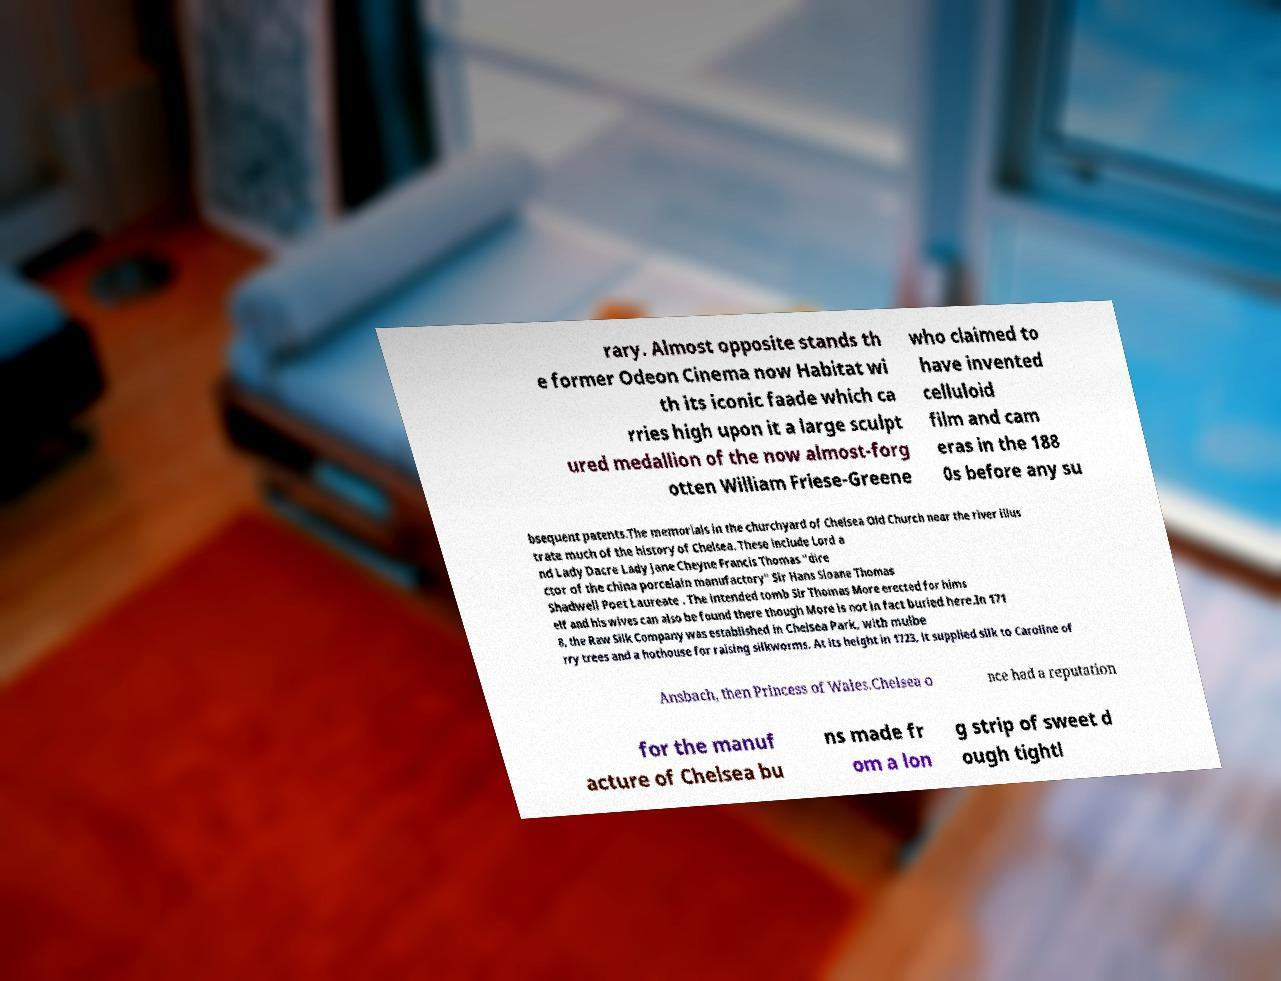Can you accurately transcribe the text from the provided image for me? rary. Almost opposite stands th e former Odeon Cinema now Habitat wi th its iconic faade which ca rries high upon it a large sculpt ured medallion of the now almost-forg otten William Friese-Greene who claimed to have invented celluloid film and cam eras in the 188 0s before any su bsequent patents.The memorials in the churchyard of Chelsea Old Church near the river illus trate much of the history of Chelsea. These include Lord a nd Lady Dacre Lady Jane Cheyne Francis Thomas "dire ctor of the china porcelain manufactory" Sir Hans Sloane Thomas Shadwell Poet Laureate . The intended tomb Sir Thomas More erected for hims elf and his wives can also be found there though More is not in fact buried here.In 171 8, the Raw Silk Company was established in Chelsea Park, with mulbe rry trees and a hothouse for raising silkworms. At its height in 1723, it supplied silk to Caroline of Ansbach, then Princess of Wales.Chelsea o nce had a reputation for the manuf acture of Chelsea bu ns made fr om a lon g strip of sweet d ough tightl 